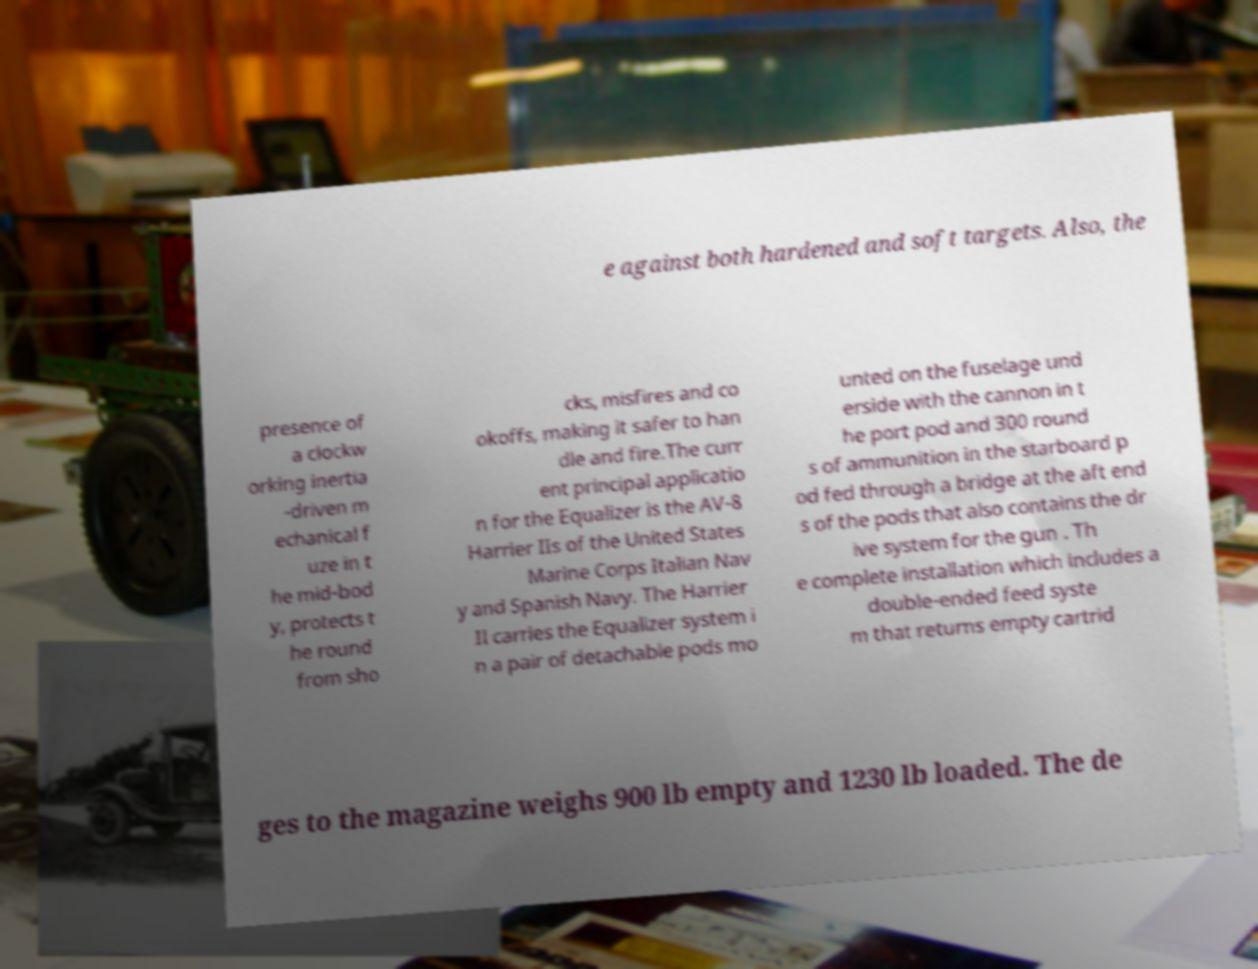Please identify and transcribe the text found in this image. e against both hardened and soft targets. Also, the presence of a clockw orking inertia -driven m echanical f uze in t he mid-bod y, protects t he round from sho cks, misfires and co okoffs, making it safer to han dle and fire.The curr ent principal applicatio n for the Equalizer is the AV-8 Harrier IIs of the United States Marine Corps Italian Nav y and Spanish Navy. The Harrier II carries the Equalizer system i n a pair of detachable pods mo unted on the fuselage und erside with the cannon in t he port pod and 300 round s of ammunition in the starboard p od fed through a bridge at the aft end s of the pods that also contains the dr ive system for the gun . Th e complete installation which includes a double-ended feed syste m that returns empty cartrid ges to the magazine weighs 900 lb empty and 1230 lb loaded. The de 